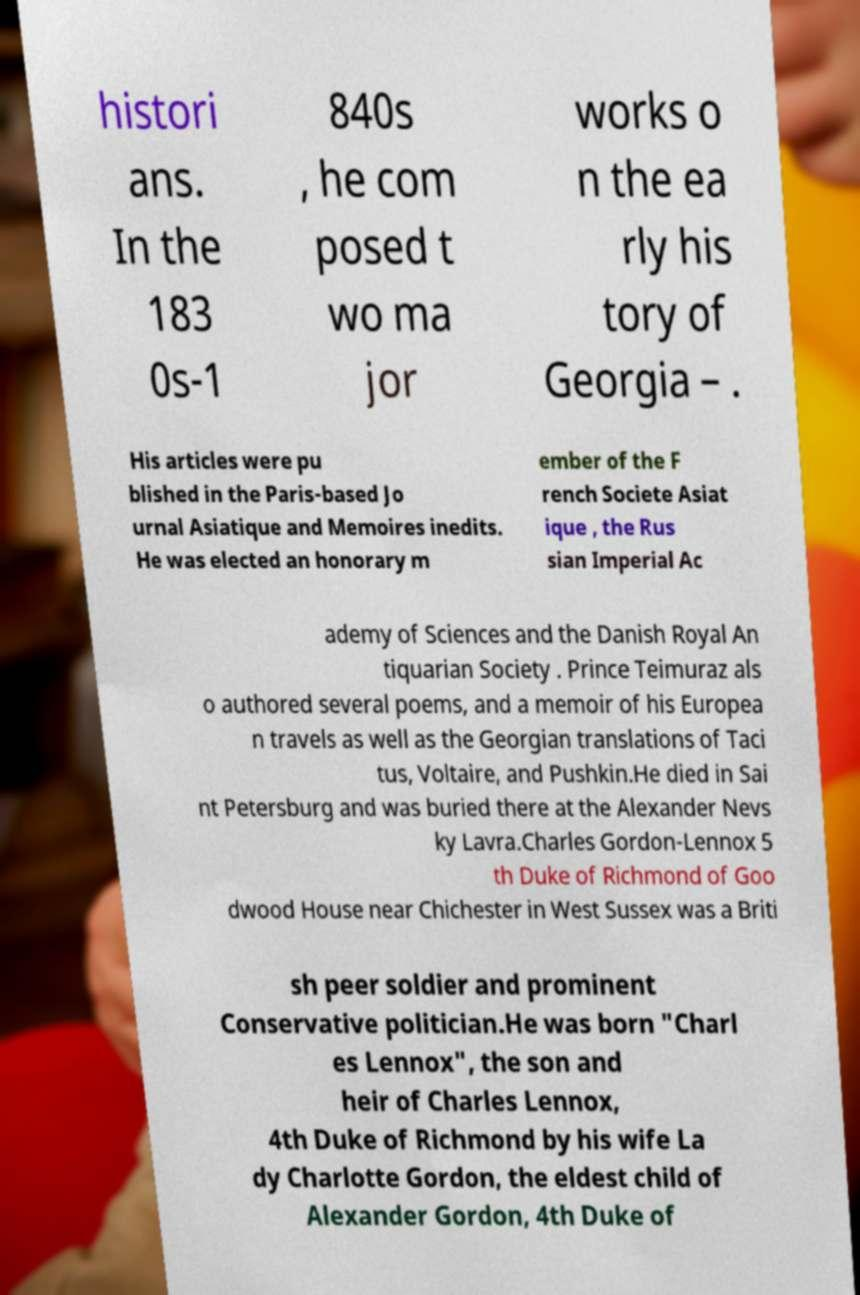Can you accurately transcribe the text from the provided image for me? histori ans. In the 183 0s-1 840s , he com posed t wo ma jor works o n the ea rly his tory of Georgia – . His articles were pu blished in the Paris-based Jo urnal Asiatique and Memoires inedits. He was elected an honorary m ember of the F rench Societe Asiat ique , the Rus sian Imperial Ac ademy of Sciences and the Danish Royal An tiquarian Society . Prince Teimuraz als o authored several poems, and a memoir of his Europea n travels as well as the Georgian translations of Taci tus, Voltaire, and Pushkin.He died in Sai nt Petersburg and was buried there at the Alexander Nevs ky Lavra.Charles Gordon-Lennox 5 th Duke of Richmond of Goo dwood House near Chichester in West Sussex was a Briti sh peer soldier and prominent Conservative politician.He was born "Charl es Lennox", the son and heir of Charles Lennox, 4th Duke of Richmond by his wife La dy Charlotte Gordon, the eldest child of Alexander Gordon, 4th Duke of 